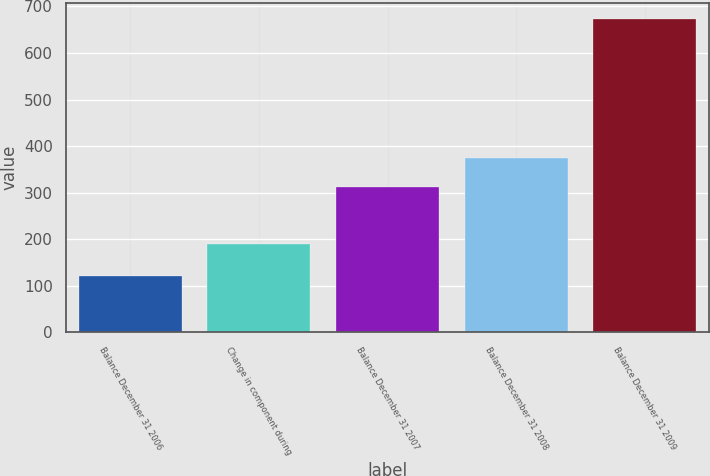<chart> <loc_0><loc_0><loc_500><loc_500><bar_chart><fcel>Balance December 31 2006<fcel>Change in component during<fcel>Balance December 31 2007<fcel>Balance December 31 2008<fcel>Balance December 31 2009<nl><fcel>122<fcel>190<fcel>312<fcel>375<fcel>674<nl></chart> 